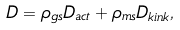Convert formula to latex. <formula><loc_0><loc_0><loc_500><loc_500>D = \rho _ { g s } D _ { a c t } + \rho _ { m s } D _ { k i n k } ,</formula> 